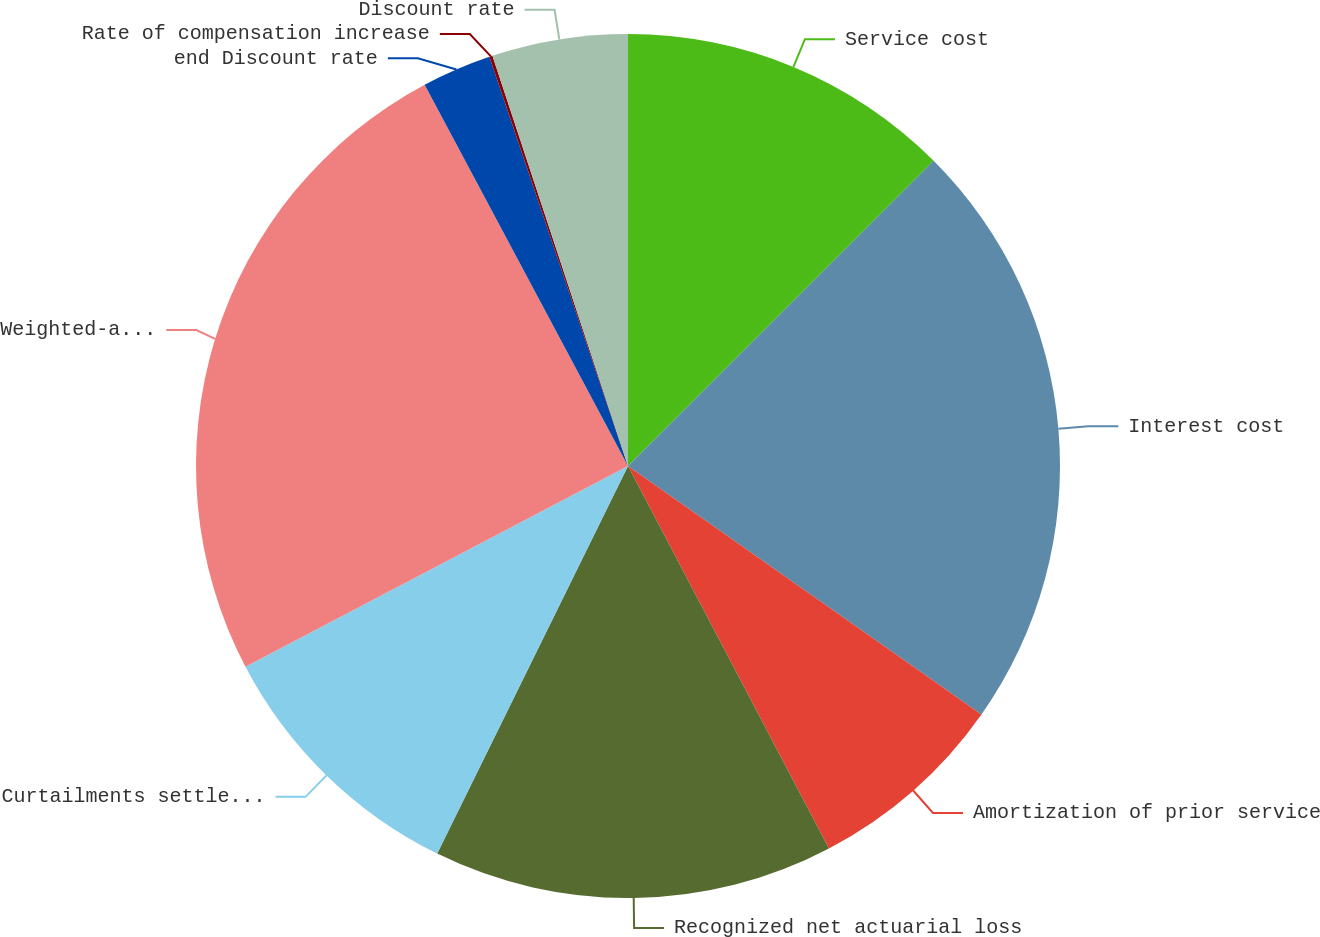Convert chart. <chart><loc_0><loc_0><loc_500><loc_500><pie_chart><fcel>Service cost<fcel>Interest cost<fcel>Amortization of prior service<fcel>Recognized net actuarial loss<fcel>Curtailments settlements and<fcel>Weighted-average assumptions<fcel>end Discount rate<fcel>Rate of compensation increase<fcel>Discount rate<nl><fcel>12.51%<fcel>22.24%<fcel>7.55%<fcel>14.98%<fcel>10.03%<fcel>24.89%<fcel>2.6%<fcel>0.12%<fcel>5.08%<nl></chart> 